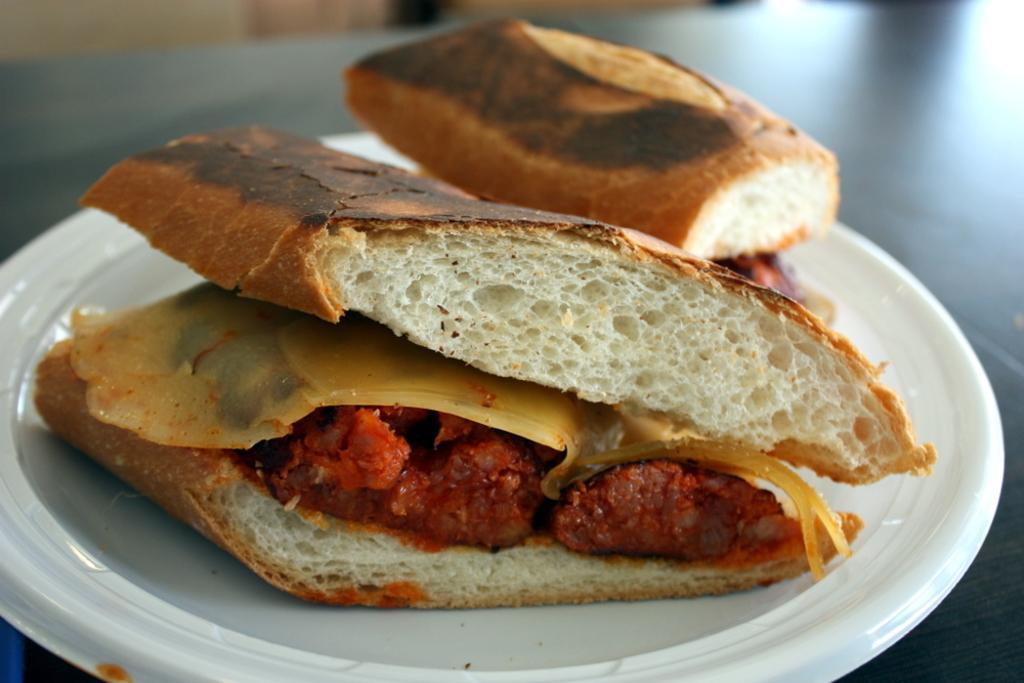Could you give a brief overview of what you see in this image? In this picture we can see a plate on the surface with food in it and in the background it is blurry. 